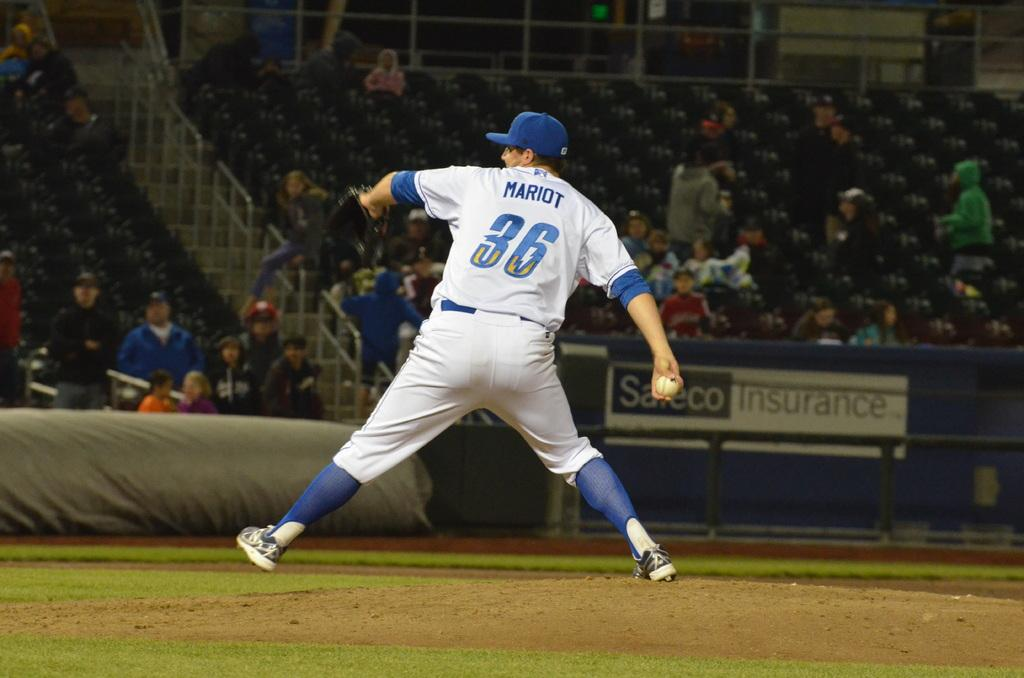<image>
Summarize the visual content of the image. Baseball player wearing number 36 pitching a ball. 